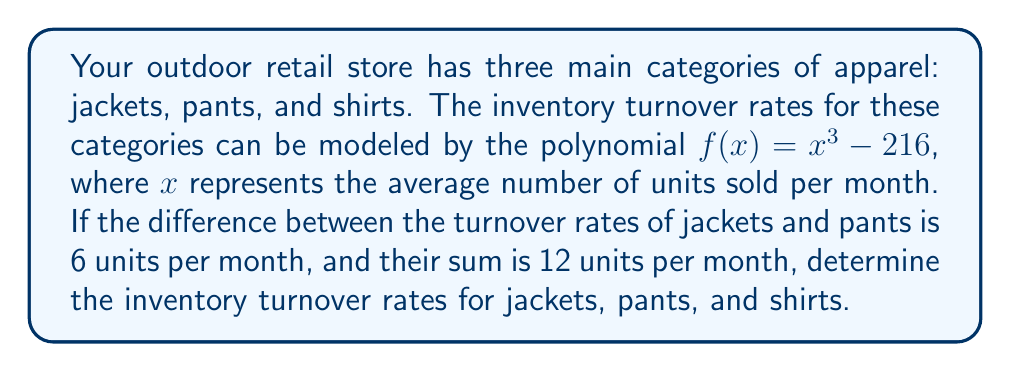What is the answer to this math problem? Let's approach this step-by-step:

1) We can use the sum and difference of cubes formulas to factor $f(x) = x^3 - 216$:

   $a^3 - b^3 = (a-b)(a^2 + ab + b^2)$

   In this case, $a = x$ and $b = 6$ (since $6^3 = 216$)

   So, $f(x) = x^3 - 216 = (x-6)(x^2 + 6x + 36)$

2) Let $j$ be the turnover rate for jackets and $p$ for pants. We're given:
   
   $j + p = 12$ (sum)
   $j - p = 6$ (difference)

3) Using these equations, we can solve for $j$ and $p$:
   
   Adding the equations: $2j = 18$
   $j = 9$

   Subtracting the equations: $2p = 6$
   $p = 3$

4) Now we know two roots of our polynomial: 9 and 3. The third root (representing shirts) must be 6, because:

   $(x-3)(x-6)(x-9) = x^3 - 18x^2 + 90x - 162$

   Expanding this: $x^3 - 18x^2 + 90x - 162 = x^3 - 216$ when $x = 6$

5) We can verify this by substituting these values into our original function:

   $f(3) = 3^3 - 216 = 27 - 216 = -189$
   $f(6) = 6^3 - 216 = 216 - 216 = 0$
   $f(9) = 9^3 - 216 = 729 - 216 = 513$

Therefore, the inventory turnover rates are 9 units/month for jackets, 3 units/month for pants, and 6 units/month for shirts.
Answer: Jackets: 9 units/month
Pants: 3 units/month
Shirts: 6 units/month 